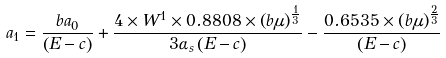<formula> <loc_0><loc_0><loc_500><loc_500>a _ { 1 } = \frac { b a _ { 0 } } { \left ( E - c \right ) } + \frac { 4 \times W ^ { 1 } \times 0 . 8 8 0 8 \times \left ( b \mu \right ) ^ { \frac { 1 } { 3 } } } { 3 \alpha _ { s } \left ( E - c \right ) } - \frac { 0 . 6 5 3 5 \times \left ( b \mu \right ) ^ { \frac { 2 } { 3 } } } { \left ( E - c \right ) }</formula> 